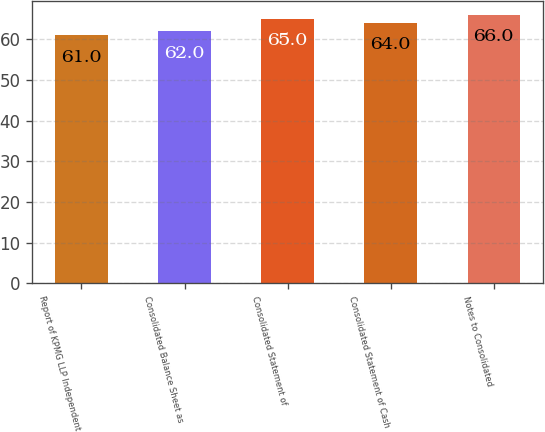Convert chart. <chart><loc_0><loc_0><loc_500><loc_500><bar_chart><fcel>Report of KPMG LLP Independent<fcel>Consolidated Balance Sheet as<fcel>Consolidated Statement of<fcel>Consolidated Statement of Cash<fcel>Notes to Consolidated<nl><fcel>61<fcel>62<fcel>65<fcel>64<fcel>66<nl></chart> 